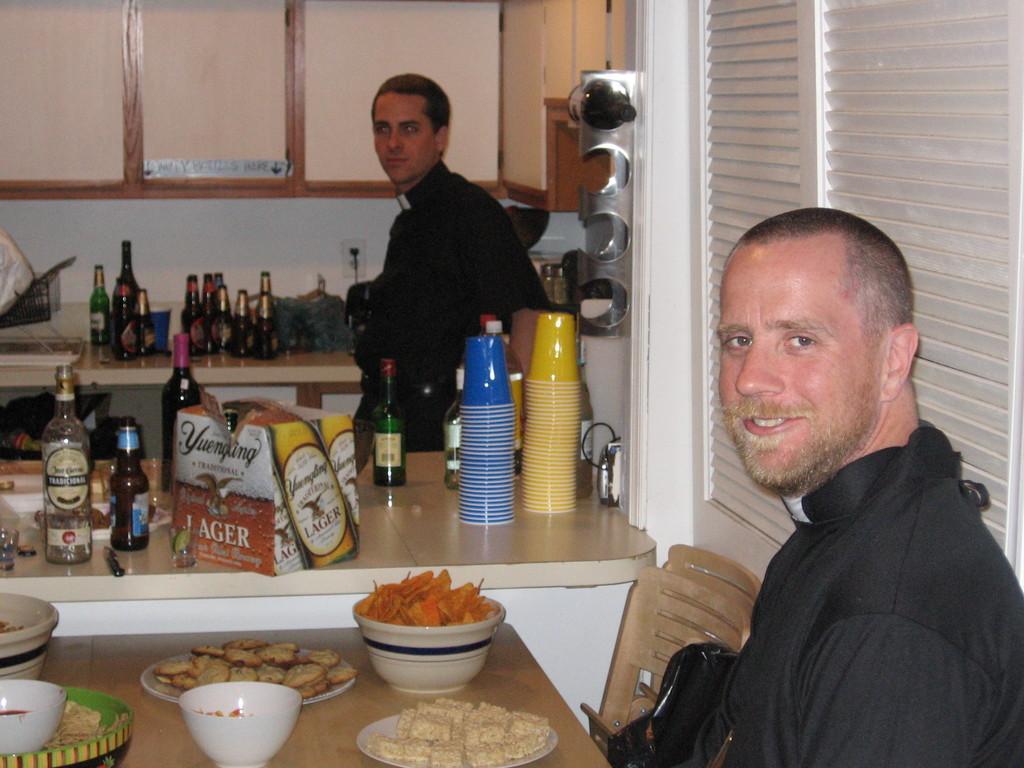Could you give a brief overview of what you see in this image? In this picture there is a man who is sitting on the chair. There is a bowl. There is a food in the plate. There is a table. There is a bottle, box and glasses and few objects on the table. There is a man who is standing. There is a cupboard. 